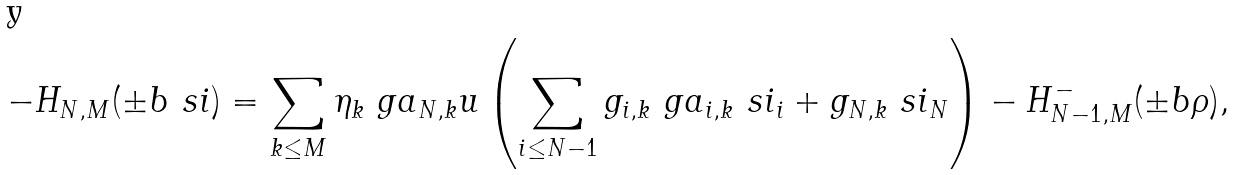<formula> <loc_0><loc_0><loc_500><loc_500>- H _ { N , M } ( \pm b { \ s i } ) = \sum _ { k \leq M } \eta _ { k } \ g a _ { N , k } u \left ( \sum _ { i \leq N - 1 } g _ { i , k } \ g a _ { i , k } \ s i _ { i } + g _ { N , k } \ s i _ { N } \right ) - H _ { N - 1 , M } ^ { - } ( \pm b { \rho } ) ,</formula> 